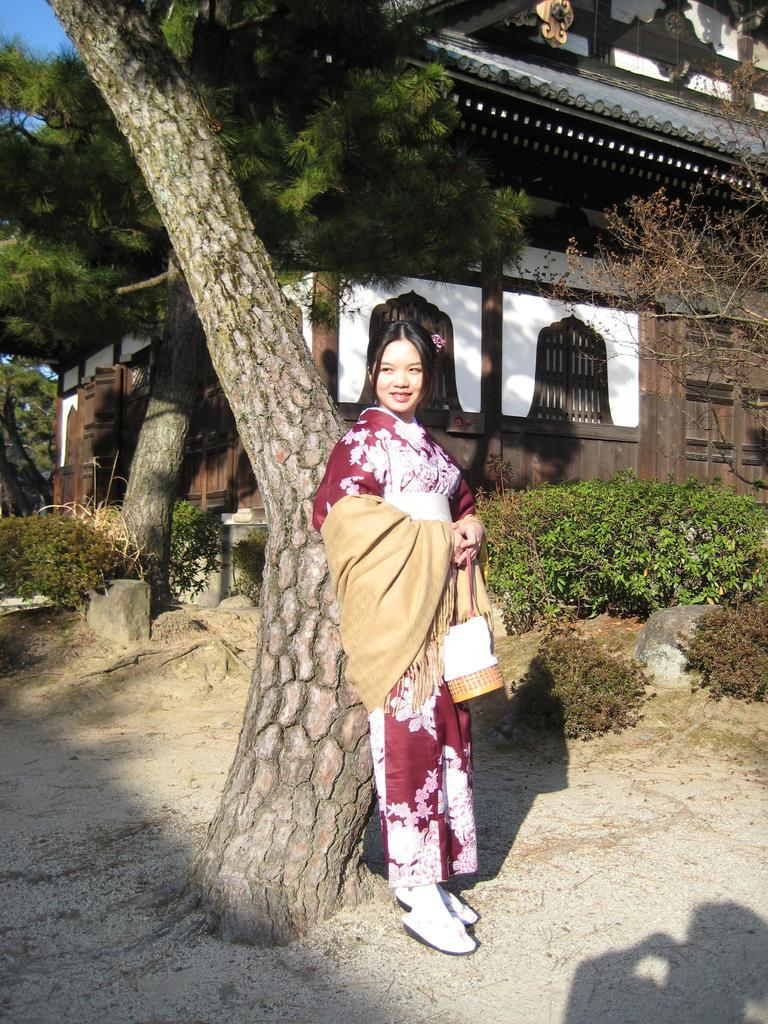What is the woman doing in the image? The woman is standing at the tree trunk in the image. What can be seen in the background of the image? There are trees visible in the image. What type of structure is present in the image? There is a house in the image. What color is the sweater the woman's partner is wearing in the image? There is no partner or sweater mentioned in the image, so we cannot answer that question. 